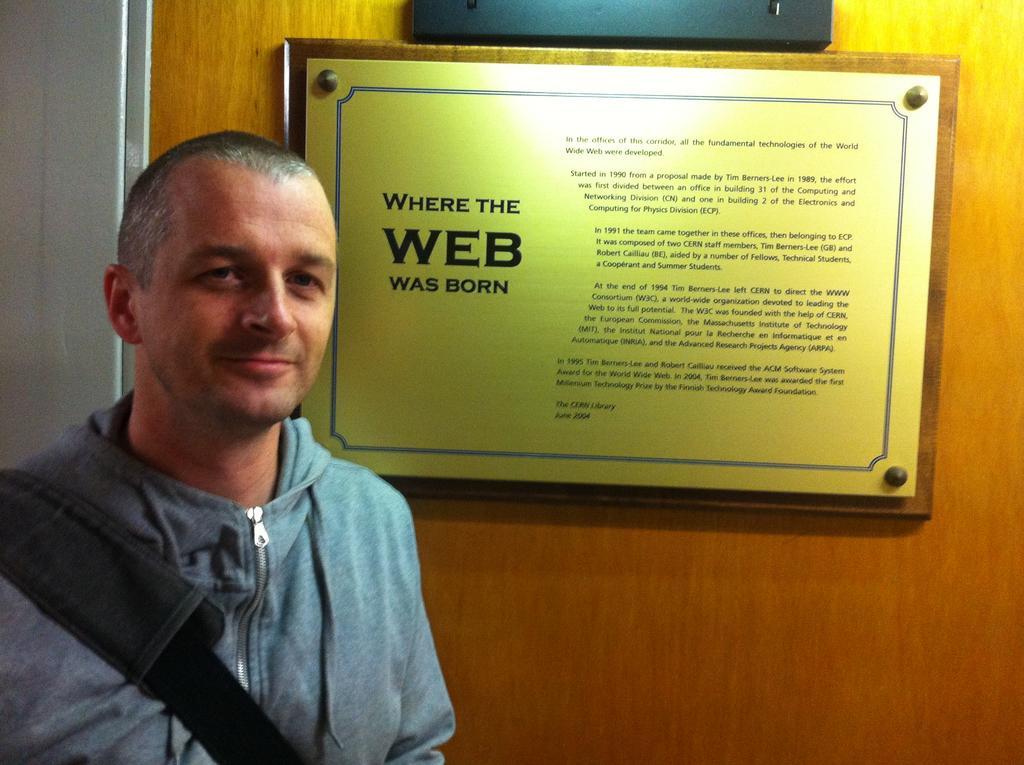Can you describe this image briefly? In this image we can see one person standing and wearing a bag. There is one text board attached to the wooden door and one object attached to the door. 